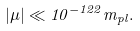Convert formula to latex. <formula><loc_0><loc_0><loc_500><loc_500>| \mu | \ll 1 0 ^ { - 1 2 2 } m _ { p l } .</formula> 